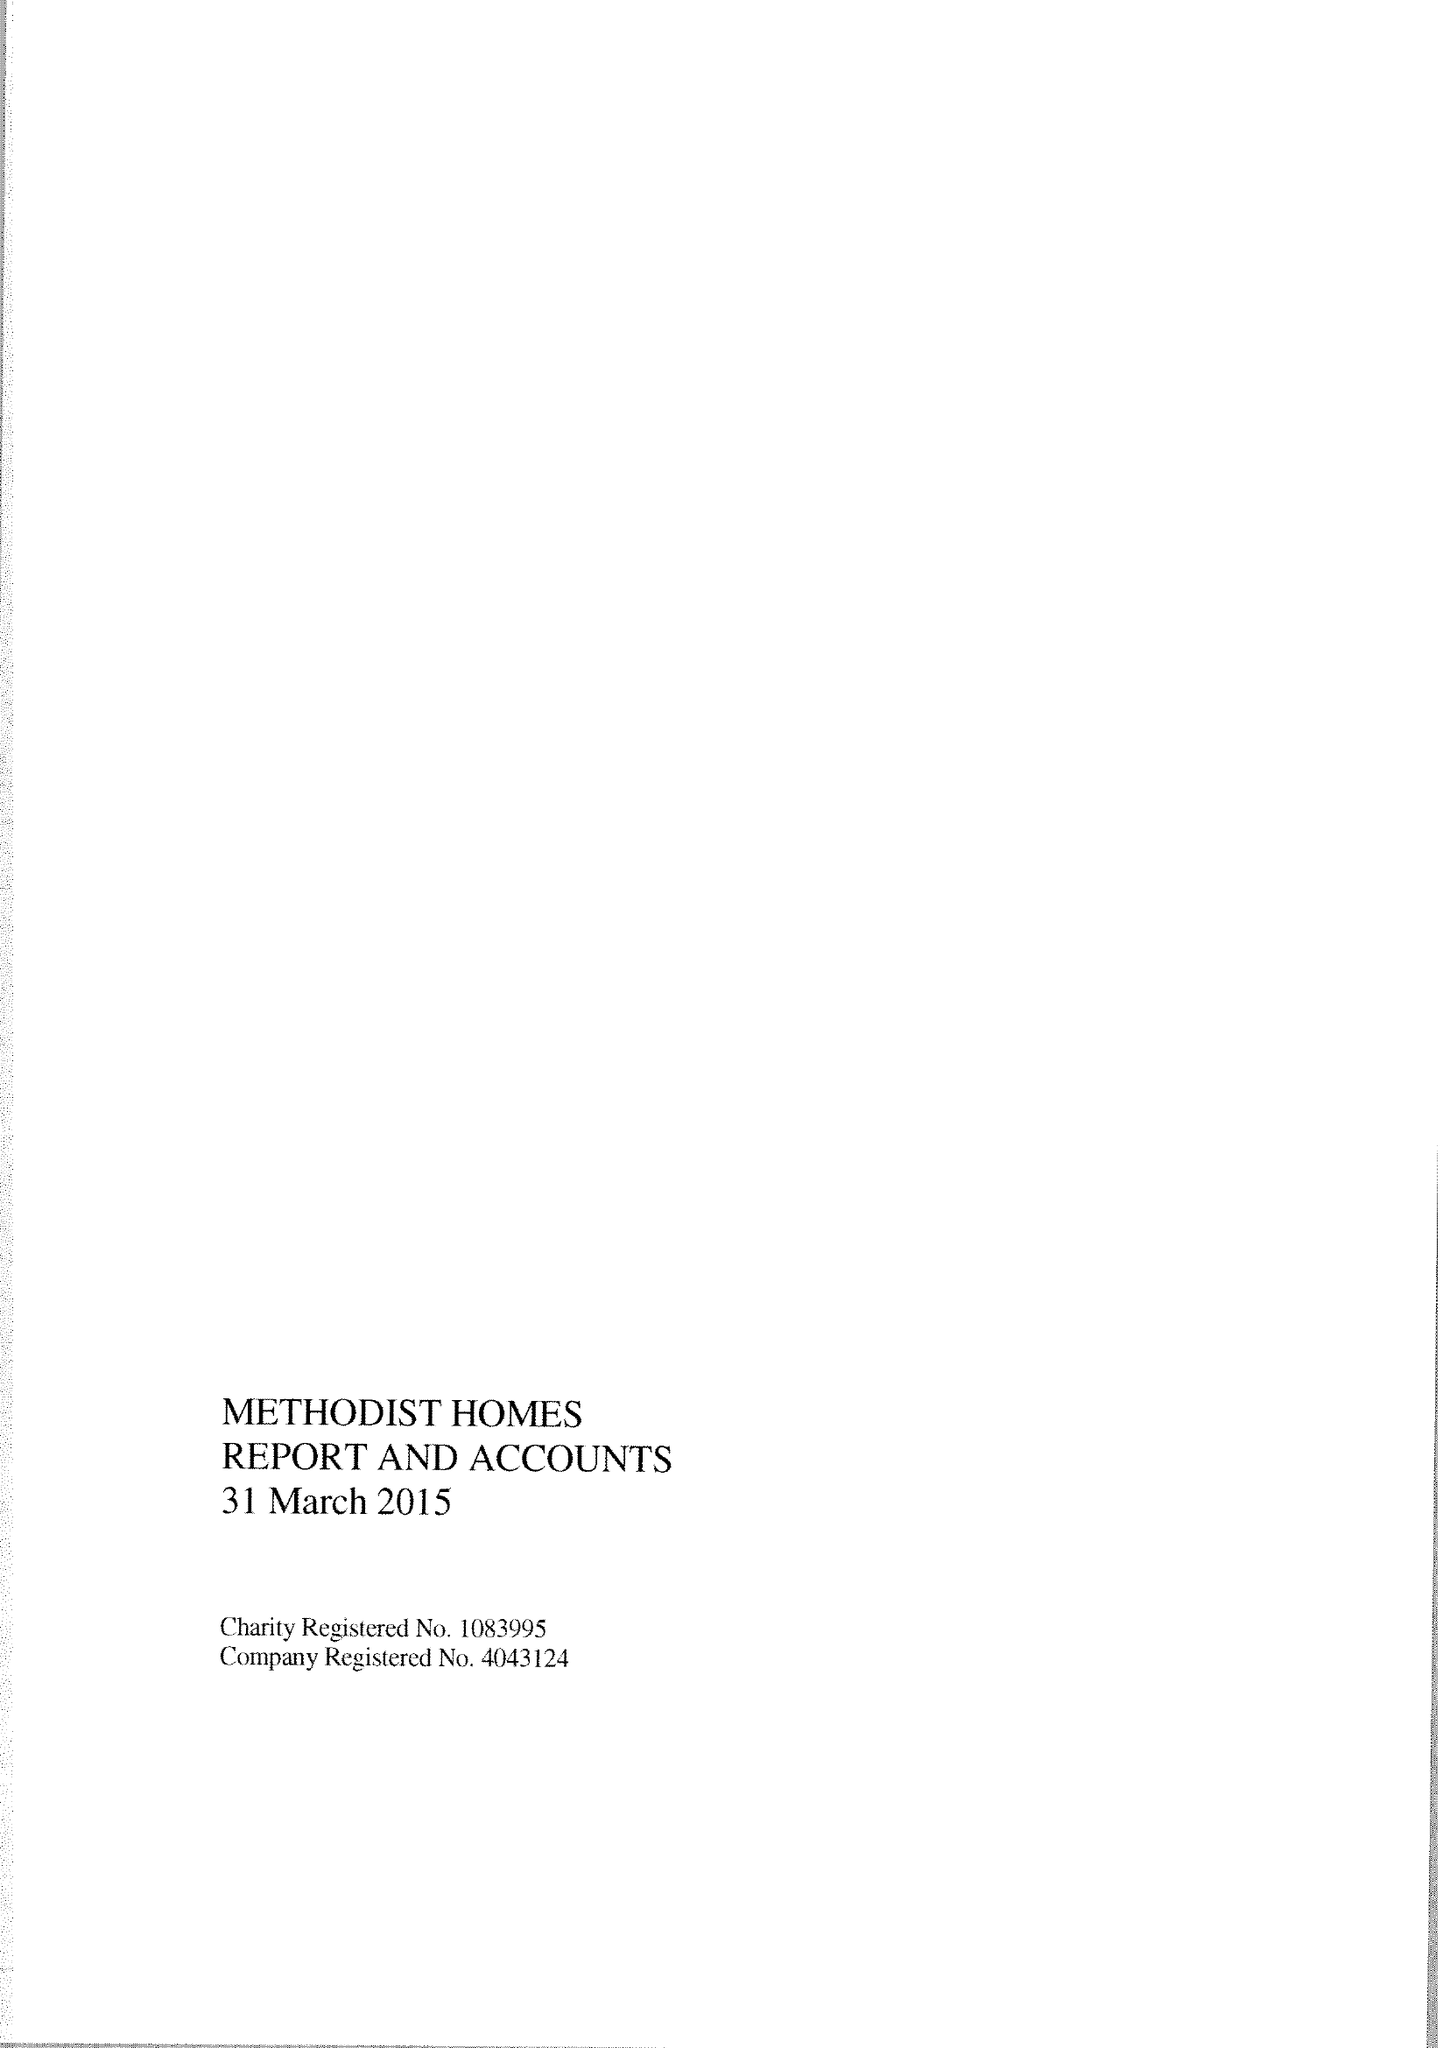What is the value for the address__postcode?
Answer the question using a single word or phrase. DE1 2EQ 